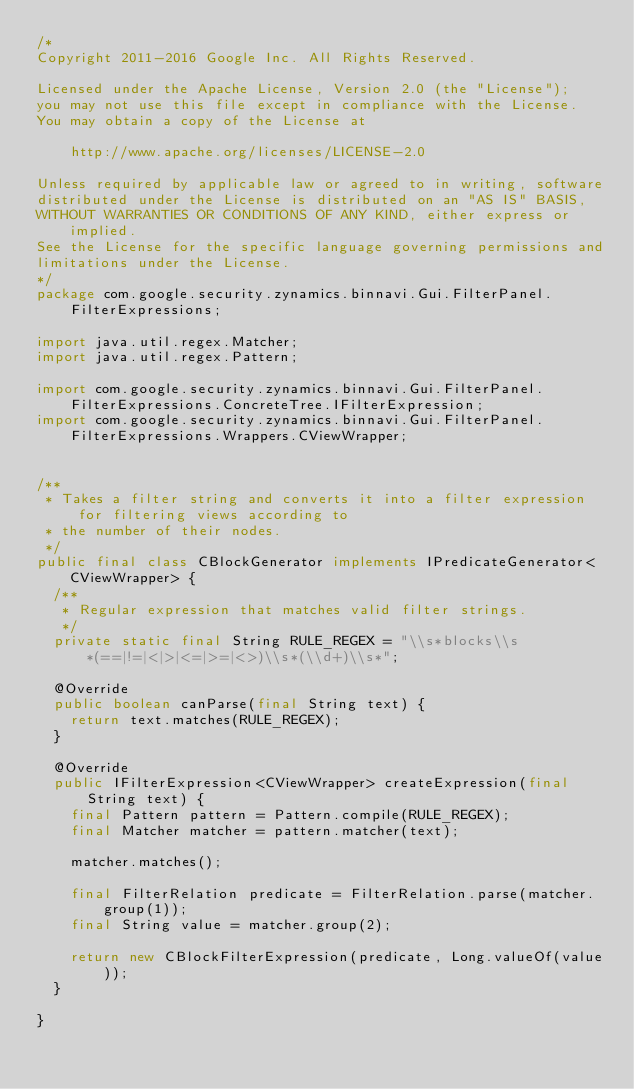<code> <loc_0><loc_0><loc_500><loc_500><_Java_>/*
Copyright 2011-2016 Google Inc. All Rights Reserved.

Licensed under the Apache License, Version 2.0 (the "License");
you may not use this file except in compliance with the License.
You may obtain a copy of the License at

    http://www.apache.org/licenses/LICENSE-2.0

Unless required by applicable law or agreed to in writing, software
distributed under the License is distributed on an "AS IS" BASIS,
WITHOUT WARRANTIES OR CONDITIONS OF ANY KIND, either express or implied.
See the License for the specific language governing permissions and
limitations under the License.
*/
package com.google.security.zynamics.binnavi.Gui.FilterPanel.FilterExpressions;

import java.util.regex.Matcher;
import java.util.regex.Pattern;

import com.google.security.zynamics.binnavi.Gui.FilterPanel.FilterExpressions.ConcreteTree.IFilterExpression;
import com.google.security.zynamics.binnavi.Gui.FilterPanel.FilterExpressions.Wrappers.CViewWrapper;


/**
 * Takes a filter string and converts it into a filter expression for filtering views according to
 * the number of their nodes.
 */
public final class CBlockGenerator implements IPredicateGenerator<CViewWrapper> {
  /**
   * Regular expression that matches valid filter strings.
   */
  private static final String RULE_REGEX = "\\s*blocks\\s*(==|!=|<|>|<=|>=|<>)\\s*(\\d+)\\s*";

  @Override
  public boolean canParse(final String text) {
    return text.matches(RULE_REGEX);
  }

  @Override
  public IFilterExpression<CViewWrapper> createExpression(final String text) {
    final Pattern pattern = Pattern.compile(RULE_REGEX);
    final Matcher matcher = pattern.matcher(text);

    matcher.matches();

    final FilterRelation predicate = FilterRelation.parse(matcher.group(1));
    final String value = matcher.group(2);

    return new CBlockFilterExpression(predicate, Long.valueOf(value));
  }

}
</code> 